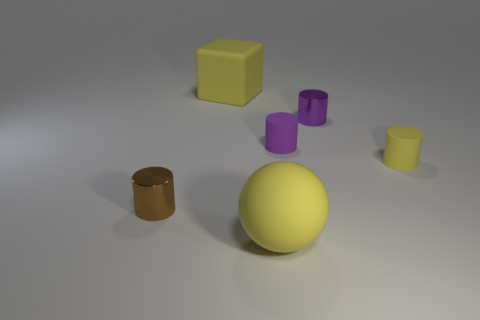What color is the thing behind the tiny metal thing that is behind the brown thing?
Offer a very short reply. Yellow. What is the material of the small cylinder that is both on the right side of the purple matte thing and behind the small yellow rubber cylinder?
Your response must be concise. Metal. Are there any other tiny things that have the same shape as the brown object?
Your response must be concise. Yes. Is the shape of the shiny object that is in front of the tiny yellow matte object the same as  the tiny purple shiny object?
Your response must be concise. Yes. What number of yellow things are both right of the tiny purple shiny cylinder and to the left of the small purple matte thing?
Keep it short and to the point. 0. There is a large yellow object that is in front of the purple shiny object; what is its shape?
Provide a short and direct response. Sphere. How many small gray cubes have the same material as the big yellow ball?
Ensure brevity in your answer.  0. Is the shape of the tiny yellow thing the same as the small purple metallic thing that is behind the sphere?
Offer a very short reply. Yes. Is there a small brown metal cylinder that is on the right side of the small cylinder to the right of the small object behind the tiny purple rubber thing?
Offer a terse response. No. There is a yellow rubber cube to the left of the purple matte cylinder; what size is it?
Your answer should be very brief. Large. 